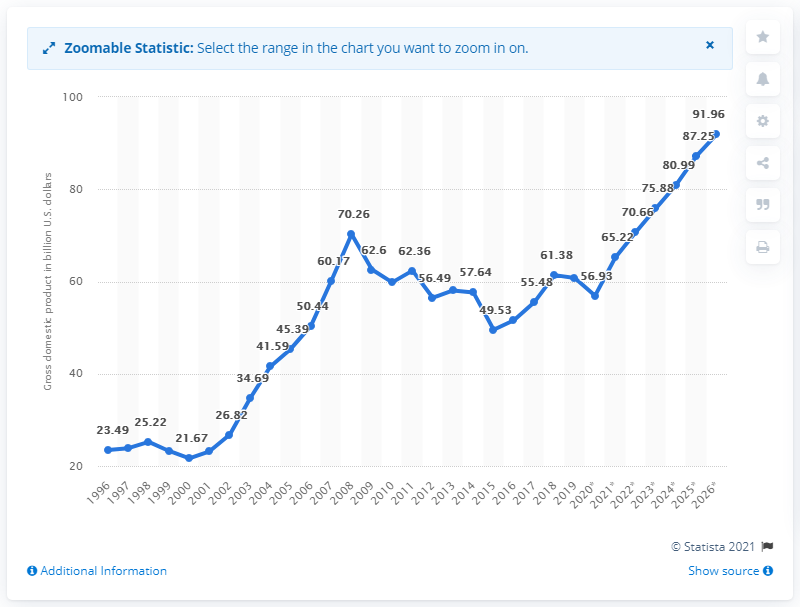Indicate a few pertinent items in this graphic. In 2019, the gross domestic product of Croatia was 60.76. 